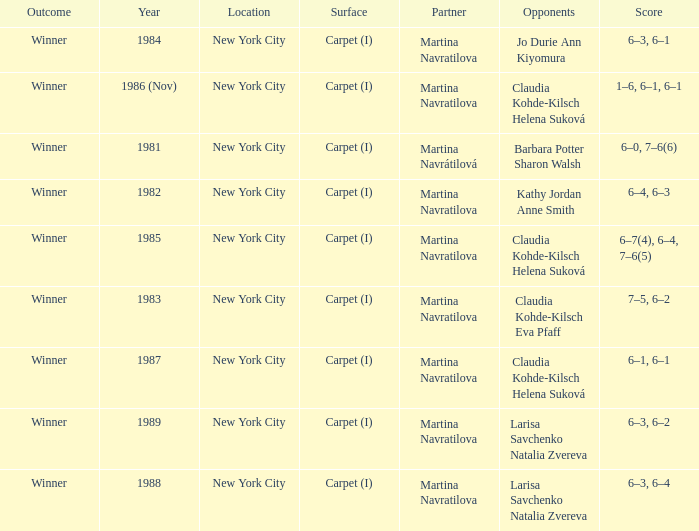Who were all of the opponents in 1984? Jo Durie Ann Kiyomura. 